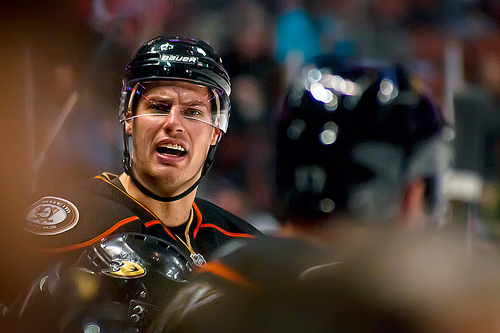<image>
Can you confirm if the helmet is on the man? Yes. Looking at the image, I can see the helmet is positioned on top of the man, with the man providing support. 